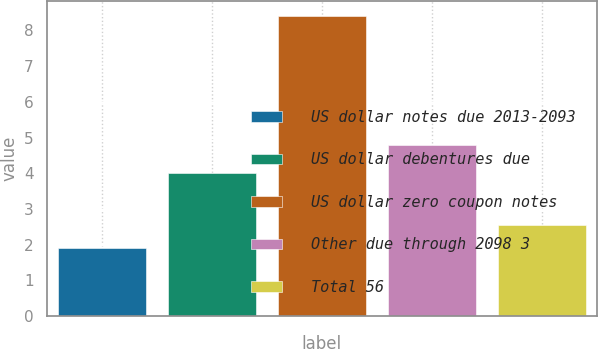Convert chart. <chart><loc_0><loc_0><loc_500><loc_500><bar_chart><fcel>US dollar notes due 2013-2093<fcel>US dollar debentures due<fcel>US dollar zero coupon notes<fcel>Other due through 2098 3<fcel>Total 56<nl><fcel>1.9<fcel>4<fcel>8.4<fcel>4.8<fcel>2.55<nl></chart> 